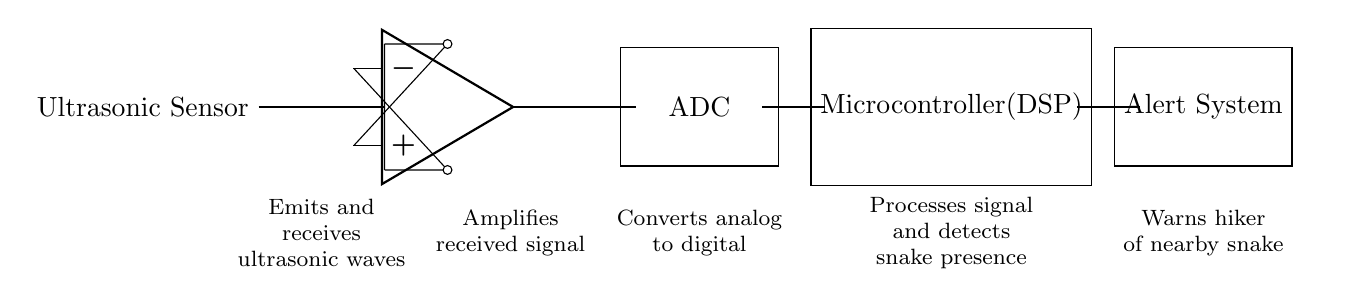What component emits and receives ultrasonic waves? The component emitting and receiving ultrasonic waves is the ultrasonic sensor, which is the first element in the circuit diagram.
Answer: Ultrasonic Sensor What is the function of the amplifier in this circuit? The amplifier's role is to amplify the received signal from the ultrasonic sensor, enhancing its strength for further processing.
Answer: Amplifies received signal What does ADC stand for in this circuit? ADC stands for Analog-to-Digital Converter, which is responsible for converting the analog signal from the amplifier into a digital signal for processing.
Answer: Analog-to-Digital Converter What is the main processing unit in this ultrasonic detection system? The main processing unit is the microcontroller specified as DSP, which processes the digital signals to detect the presence of snakes.
Answer: Microcontroller What is the output of the system used for? The output system is used for warning the hiker of any nearby snakes based on the processed signal.
Answer: Alert System How does the system detect the presence of snakes? The system detects the presence of snakes by processing the reflected ultrasonic waves from the surroundings through the microcontroller, which recognizes specific patterns associated with snake presence.
Answer: Processes signal and detects snake presence What is the role of the ultrasonic waves in this system? The role of ultrasonic waves is to create a barrier that will reflect off objects in the environment; the system analyzes these reflections to identify the presence of snakes.
Answer: Emits and receives ultrasonic waves 